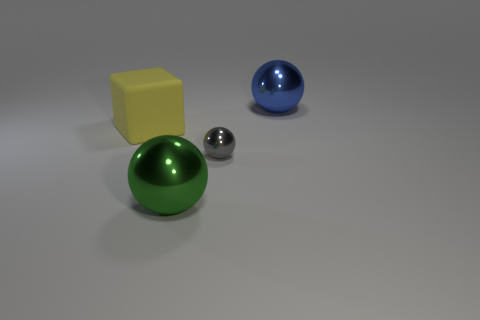Is there any other thing that is made of the same material as the big cube?
Offer a terse response. No. There is a tiny shiny thing that is the same shape as the large green object; what color is it?
Keep it short and to the point. Gray. Are there any other things that are the same shape as the blue thing?
Make the answer very short. Yes. There is a large ball that is right of the big metallic sphere that is in front of the tiny gray shiny object; is there a yellow cube on the right side of it?
Your answer should be very brief. No. What number of blue balls have the same material as the green sphere?
Keep it short and to the point. 1. There is a metal ball that is behind the large yellow thing; is it the same size as the green metal sphere right of the cube?
Offer a terse response. Yes. What is the color of the big thing that is behind the large yellow block on the left side of the large sphere that is behind the cube?
Keep it short and to the point. Blue. Is there a small yellow shiny object that has the same shape as the big yellow thing?
Your answer should be compact. No. Are there the same number of green metallic things to the right of the small object and large objects that are behind the big yellow rubber cube?
Provide a short and direct response. No. There is a big thing that is in front of the large yellow rubber thing; is its shape the same as the yellow object?
Provide a short and direct response. No. 